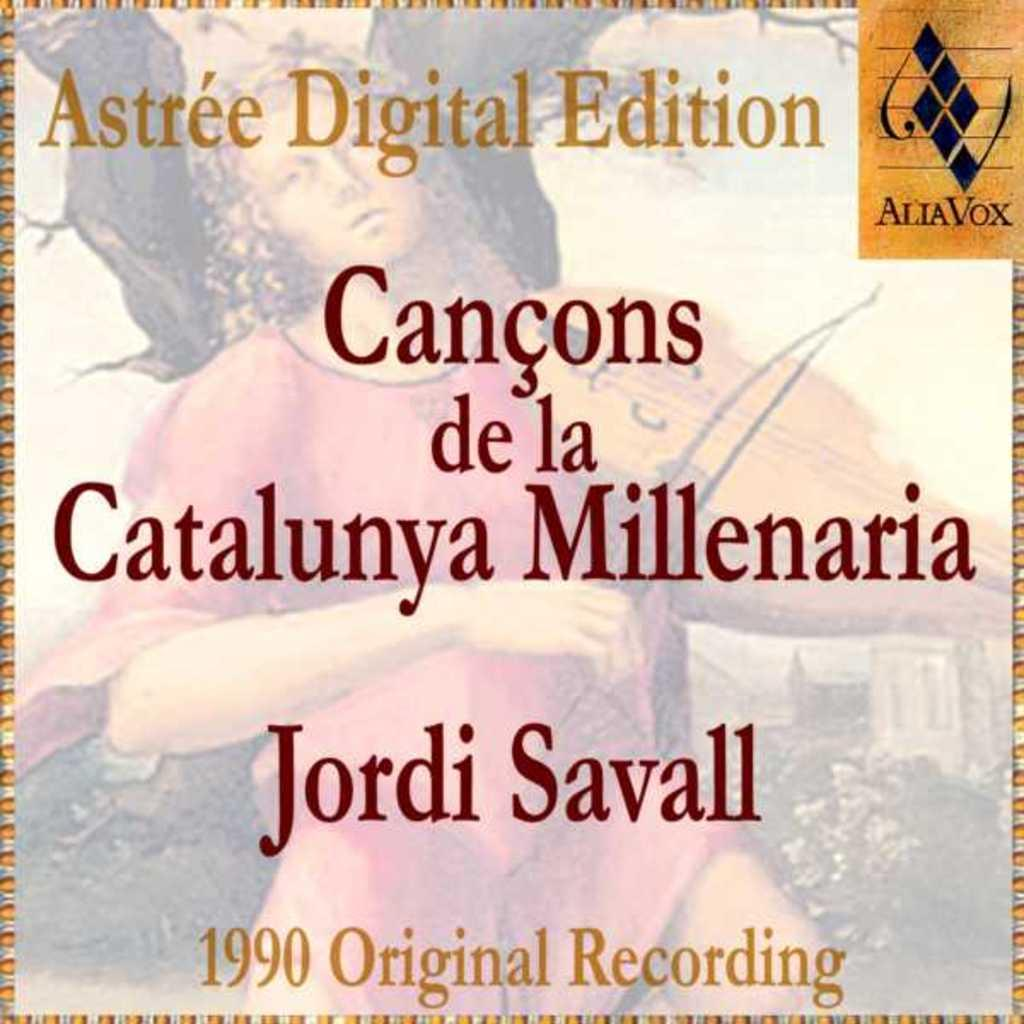Provide a one-sentence caption for the provided image. Astree digital edition of canons de la catalunya Millenaria. 